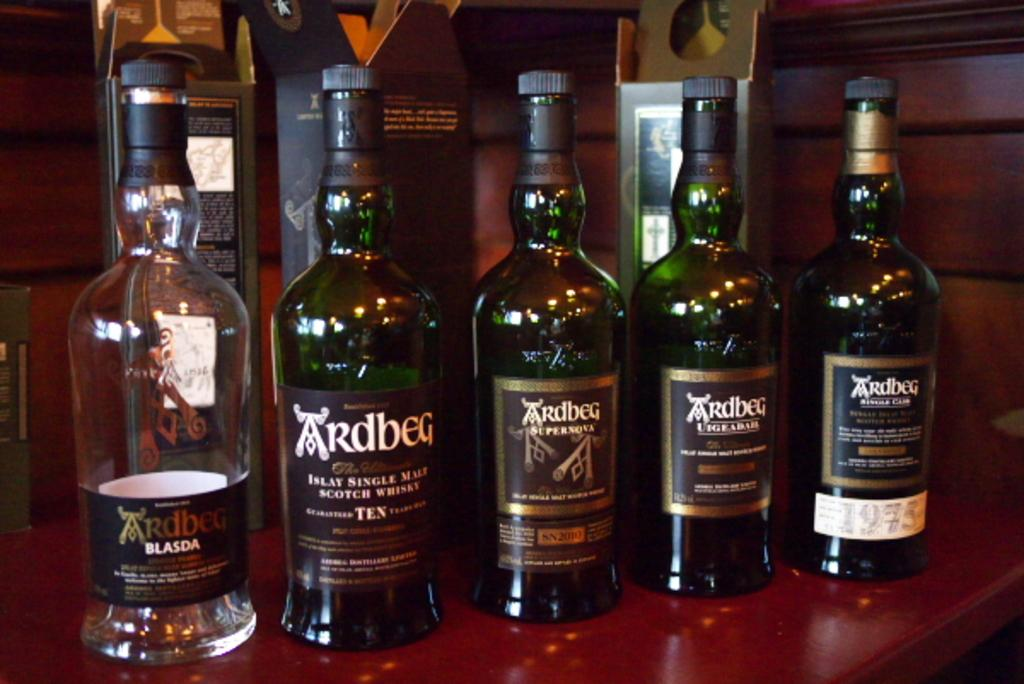<image>
Relay a brief, clear account of the picture shown. A bottle of single malt scotch whisky sits with other bottles on the bar. 